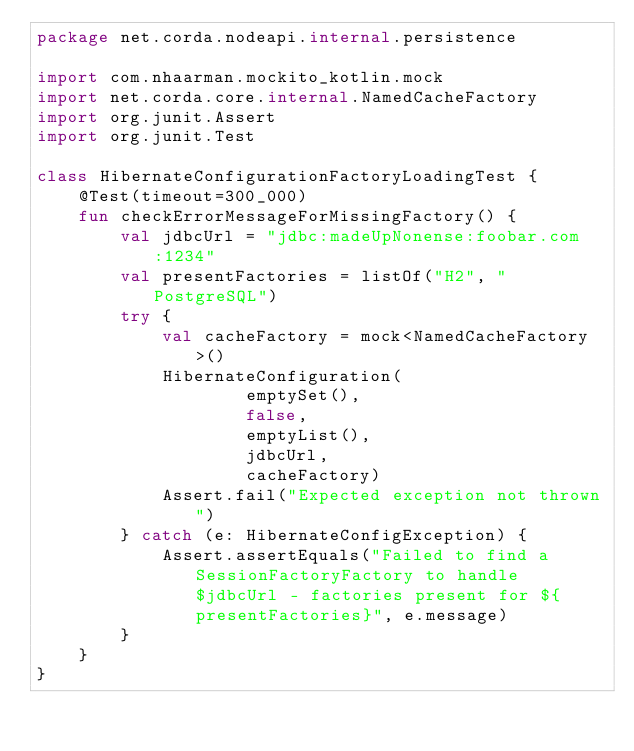<code> <loc_0><loc_0><loc_500><loc_500><_Kotlin_>package net.corda.nodeapi.internal.persistence

import com.nhaarman.mockito_kotlin.mock
import net.corda.core.internal.NamedCacheFactory
import org.junit.Assert
import org.junit.Test

class HibernateConfigurationFactoryLoadingTest {
    @Test(timeout=300_000)
    fun checkErrorMessageForMissingFactory() {
        val jdbcUrl = "jdbc:madeUpNonense:foobar.com:1234"
        val presentFactories = listOf("H2", "PostgreSQL")
        try {
            val cacheFactory = mock<NamedCacheFactory>()
            HibernateConfiguration(
                    emptySet(),
                    false,
                    emptyList(),
                    jdbcUrl,
                    cacheFactory)
            Assert.fail("Expected exception not thrown")
        } catch (e: HibernateConfigException) {
            Assert.assertEquals("Failed to find a SessionFactoryFactory to handle $jdbcUrl - factories present for ${presentFactories}", e.message)
        }
    }
}</code> 